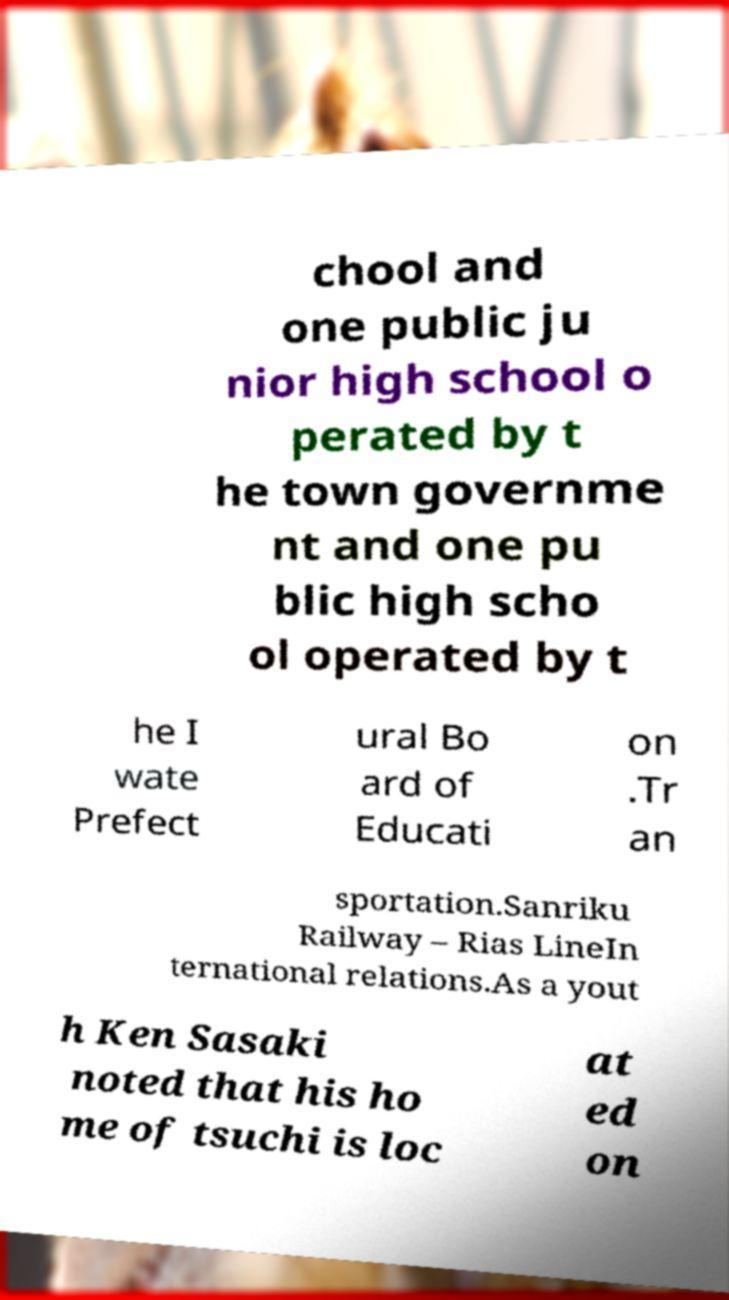Could you extract and type out the text from this image? chool and one public ju nior high school o perated by t he town governme nt and one pu blic high scho ol operated by t he I wate Prefect ural Bo ard of Educati on .Tr an sportation.Sanriku Railway – Rias LineIn ternational relations.As a yout h Ken Sasaki noted that his ho me of tsuchi is loc at ed on 